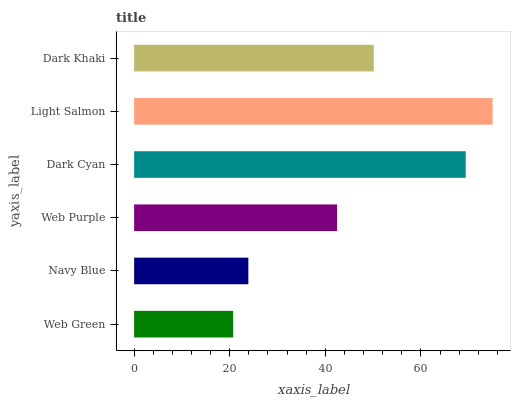Is Web Green the minimum?
Answer yes or no. Yes. Is Light Salmon the maximum?
Answer yes or no. Yes. Is Navy Blue the minimum?
Answer yes or no. No. Is Navy Blue the maximum?
Answer yes or no. No. Is Navy Blue greater than Web Green?
Answer yes or no. Yes. Is Web Green less than Navy Blue?
Answer yes or no. Yes. Is Web Green greater than Navy Blue?
Answer yes or no. No. Is Navy Blue less than Web Green?
Answer yes or no. No. Is Dark Khaki the high median?
Answer yes or no. Yes. Is Web Purple the low median?
Answer yes or no. Yes. Is Web Purple the high median?
Answer yes or no. No. Is Light Salmon the low median?
Answer yes or no. No. 